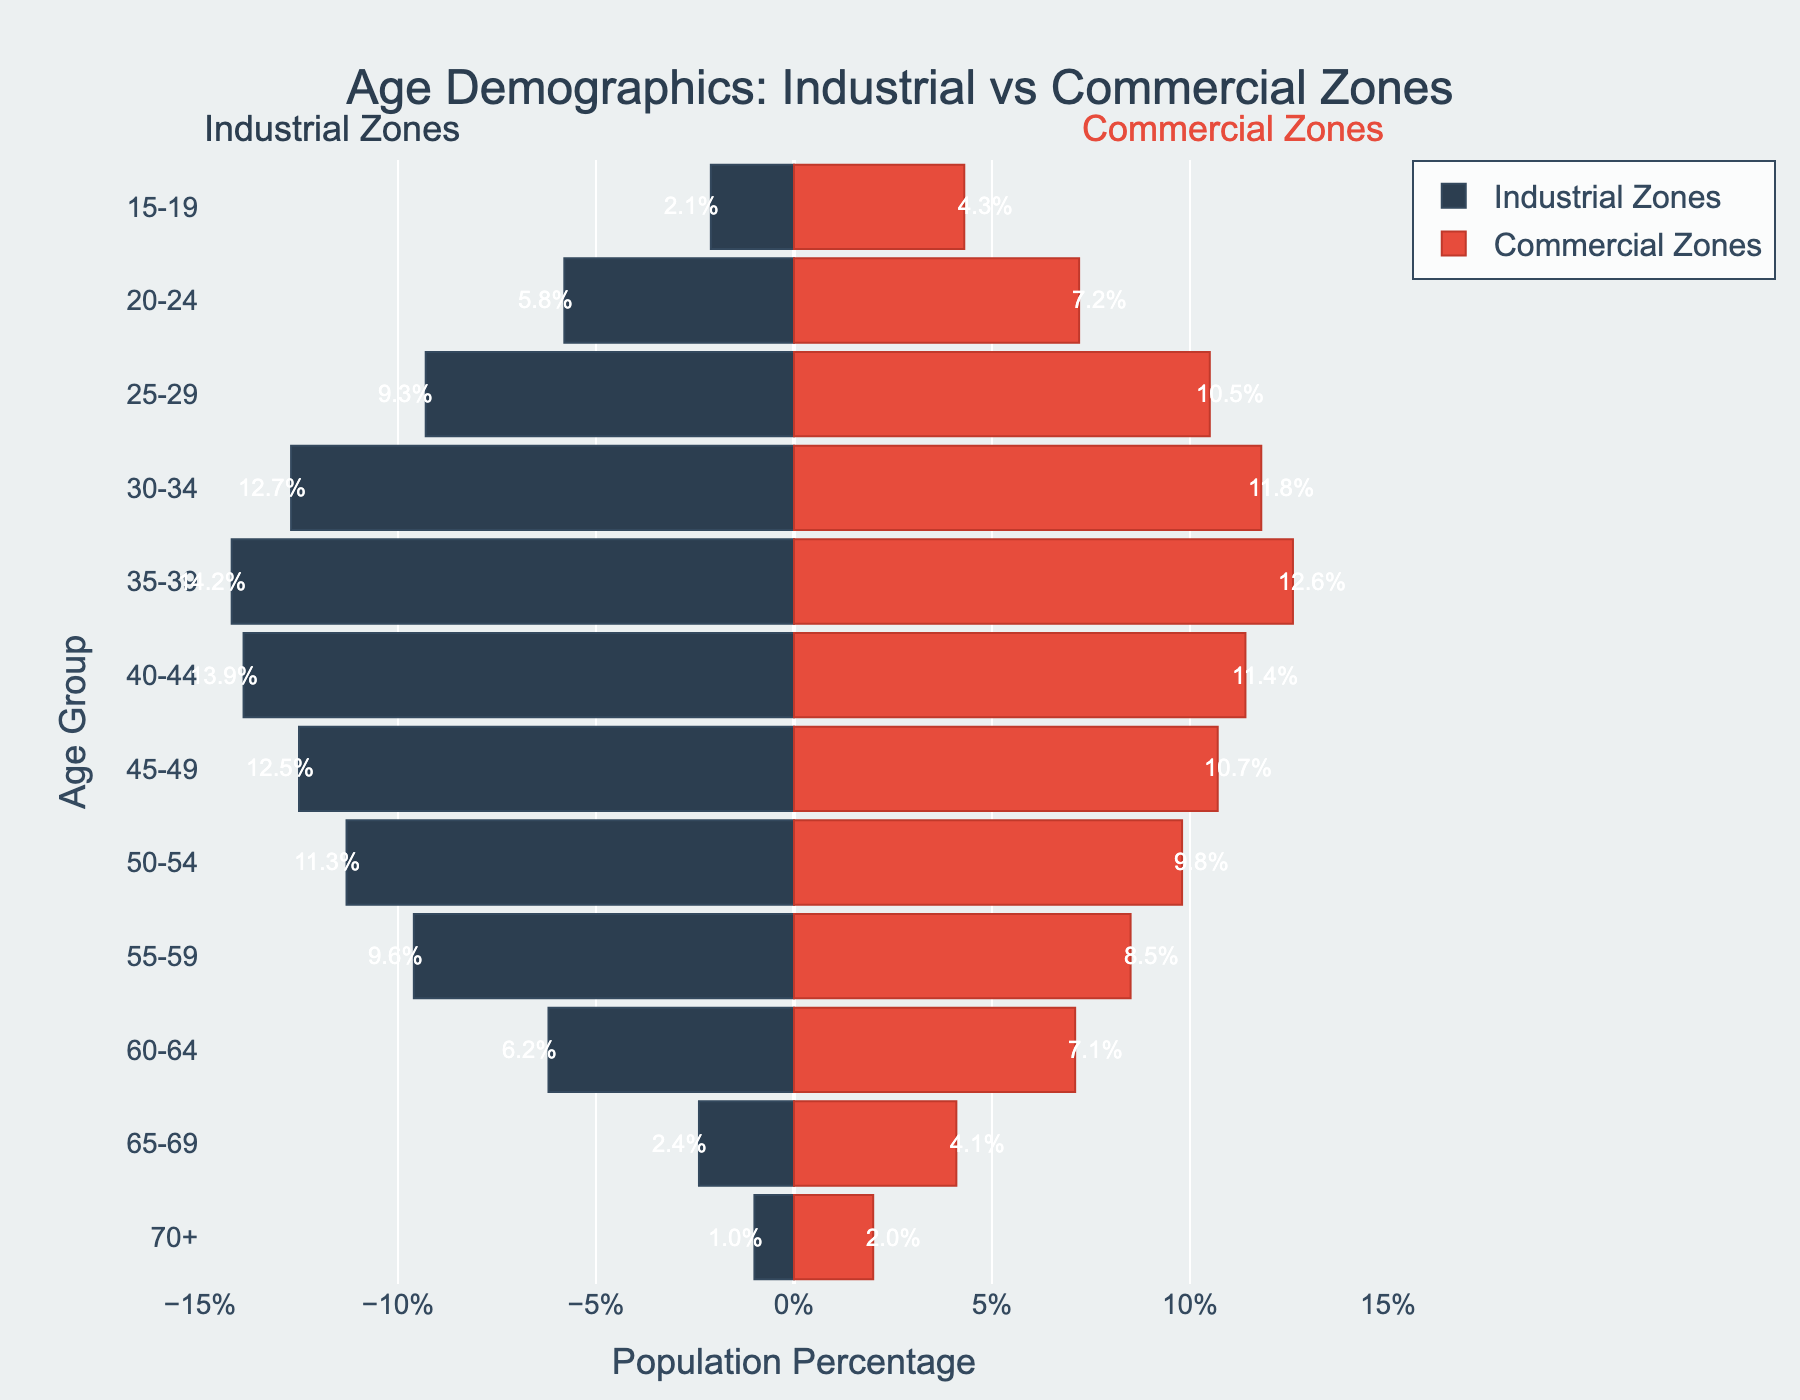What is the title of the plot? The title can be found at the top of the plot, which summarizes what the plot represents: "Age Demographics: Industrial vs Commercial Zones".
Answer: Age Demographics: Industrial vs Commercial Zones Which age group has the highest percentage in Industrial Zones? Look at the bars on the industrial zone side (left side of centerline) and determine which bar extends the farthest. The age group 35-39 has the highest percentage at 14.2%.
Answer: 35-39 What is the percentage of workers aged 50-54 in Commercial Zones? Locate the bar for the 50-54 age group on the right side (Commercial Zones) and read its value. This bar is labeled with 9.8%.
Answer: 9.8% How do the percentages for the age group 20-24 compare between Industrial and Commercial Zones? Check the bars representing the 20-24 age group on both sides of the plot. The respective values are 5.8% for Industrial Zones and 7.2% for Commercial Zones.
Answer: Commercial Zones (7.2%) is higher than Industrial Zones (5.8%) What is the difference in the population percentages between the age groups 40-44 and 45-49 in Industrial Zones? Identify the bars for the age groups 40-44 and 45-49 in the Industrial Zones. The percentages are 13.9% and 12.5% respectively. Subtract the smaller percentage from the larger: 13.9% - 12.5% = 1.4%.
Answer: 1.4% Which age group has the smallest representation in Industrial Zones? Locate the bar for the smallest age group in Industrial Zones, indicated by the shortest bar which is the 70+ age group at 1.0%.
Answer: 70+ Compare the percentage of workers aged 65-69 in both zones. Which zone has a higher representation? For the 65-69 age group, find the respective bars in both zones and compare their values. Industrial Zones have 2.4%, while Commercial Zones have 4.1%. Thus, Commercial Zones have a higher percentage.
Answer: Commercial Zones In the 30-34 age group, which zone has a higher percentage of workforce? Compare bars of the 30-34 age group for both Industrial and Commercial Zones. Industrial Zones have 12.7% and Commercial Zones have 11.8%. So, Industrial Zones have a higher percentage.
Answer: Industrial Zones What is the combined percentage of workers aged 60-64 in both zones? Add the percentage values of the 60-64 age group for both Industrial Zones (6.2%) and Commercial Zones (7.1%). 6.2% + 7.1% = 13.3%.
Answer: 13.3% 